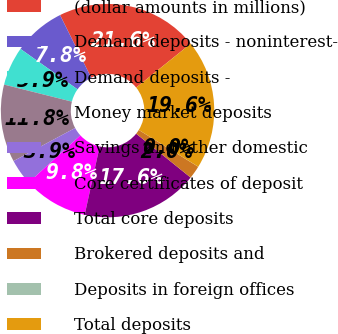Convert chart. <chart><loc_0><loc_0><loc_500><loc_500><pie_chart><fcel>(dollar amounts in millions)<fcel>Demand deposits - noninterest-<fcel>Demand deposits -<fcel>Money market deposits<fcel>Savings and other domestic<fcel>Core certificates of deposit<fcel>Total core deposits<fcel>Brokered deposits and<fcel>Deposits in foreign offices<fcel>Total deposits<nl><fcel>21.56%<fcel>7.85%<fcel>5.89%<fcel>11.76%<fcel>3.93%<fcel>9.8%<fcel>17.64%<fcel>1.97%<fcel>0.01%<fcel>19.6%<nl></chart> 